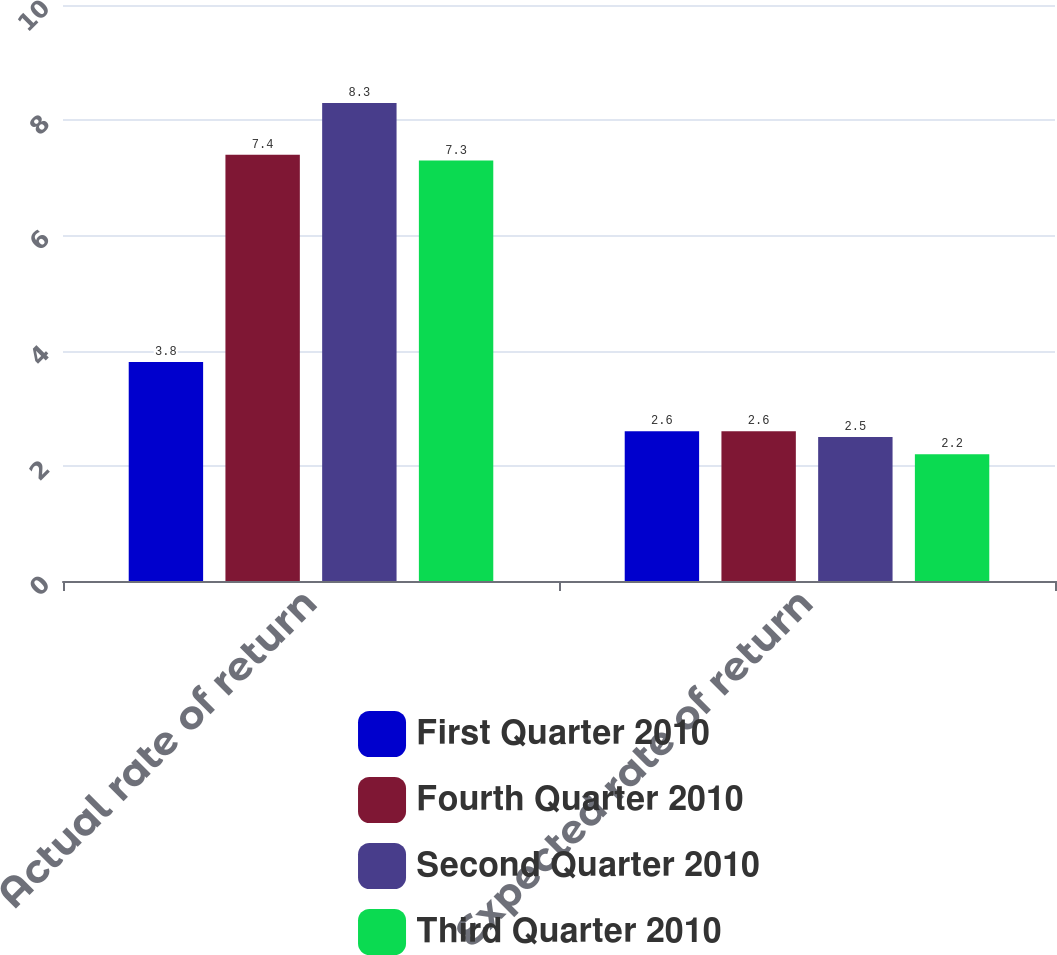Convert chart. <chart><loc_0><loc_0><loc_500><loc_500><stacked_bar_chart><ecel><fcel>Actual rate of return<fcel>Expected rate of return<nl><fcel>First Quarter 2010<fcel>3.8<fcel>2.6<nl><fcel>Fourth Quarter 2010<fcel>7.4<fcel>2.6<nl><fcel>Second Quarter 2010<fcel>8.3<fcel>2.5<nl><fcel>Third Quarter 2010<fcel>7.3<fcel>2.2<nl></chart> 